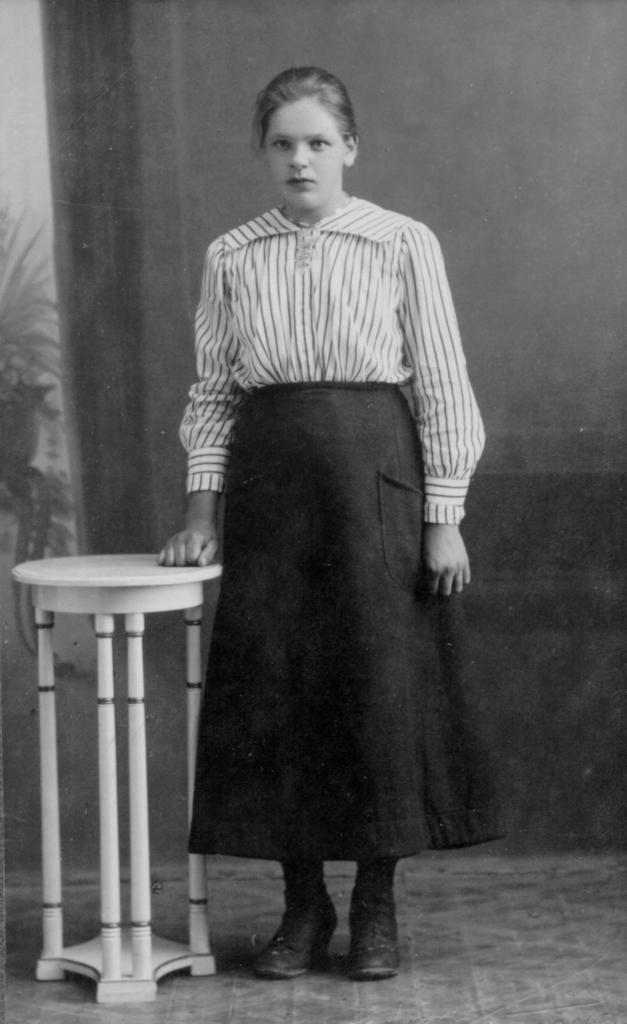What is the person in the image wearing? There is a person with a dress in the image. What object is to the left of the person? There is a stool to the left of the person. What other object is to the left of the person? There is a plant to the left of the person. How is the image presented in terms of color? The image is black and white. What type of mint can be seen growing on the person's dress in the image? There is no mint present in the image, and the person's dress does not have any plants growing on it. 